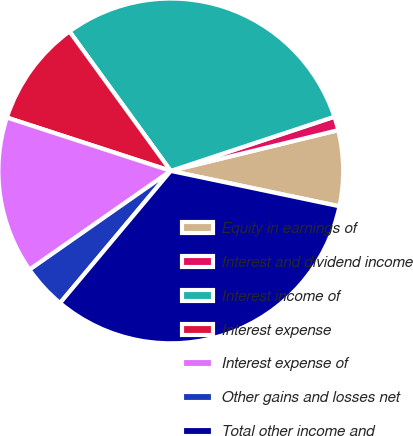<chart> <loc_0><loc_0><loc_500><loc_500><pie_chart><fcel>Equity in earnings of<fcel>Interest and dividend income<fcel>Interest income of<fcel>Interest expense<fcel>Interest expense of<fcel>Other gains and losses net<fcel>Total other income and<nl><fcel>7.09%<fcel>1.29%<fcel>29.91%<fcel>9.99%<fcel>14.72%<fcel>4.19%<fcel>32.81%<nl></chart> 